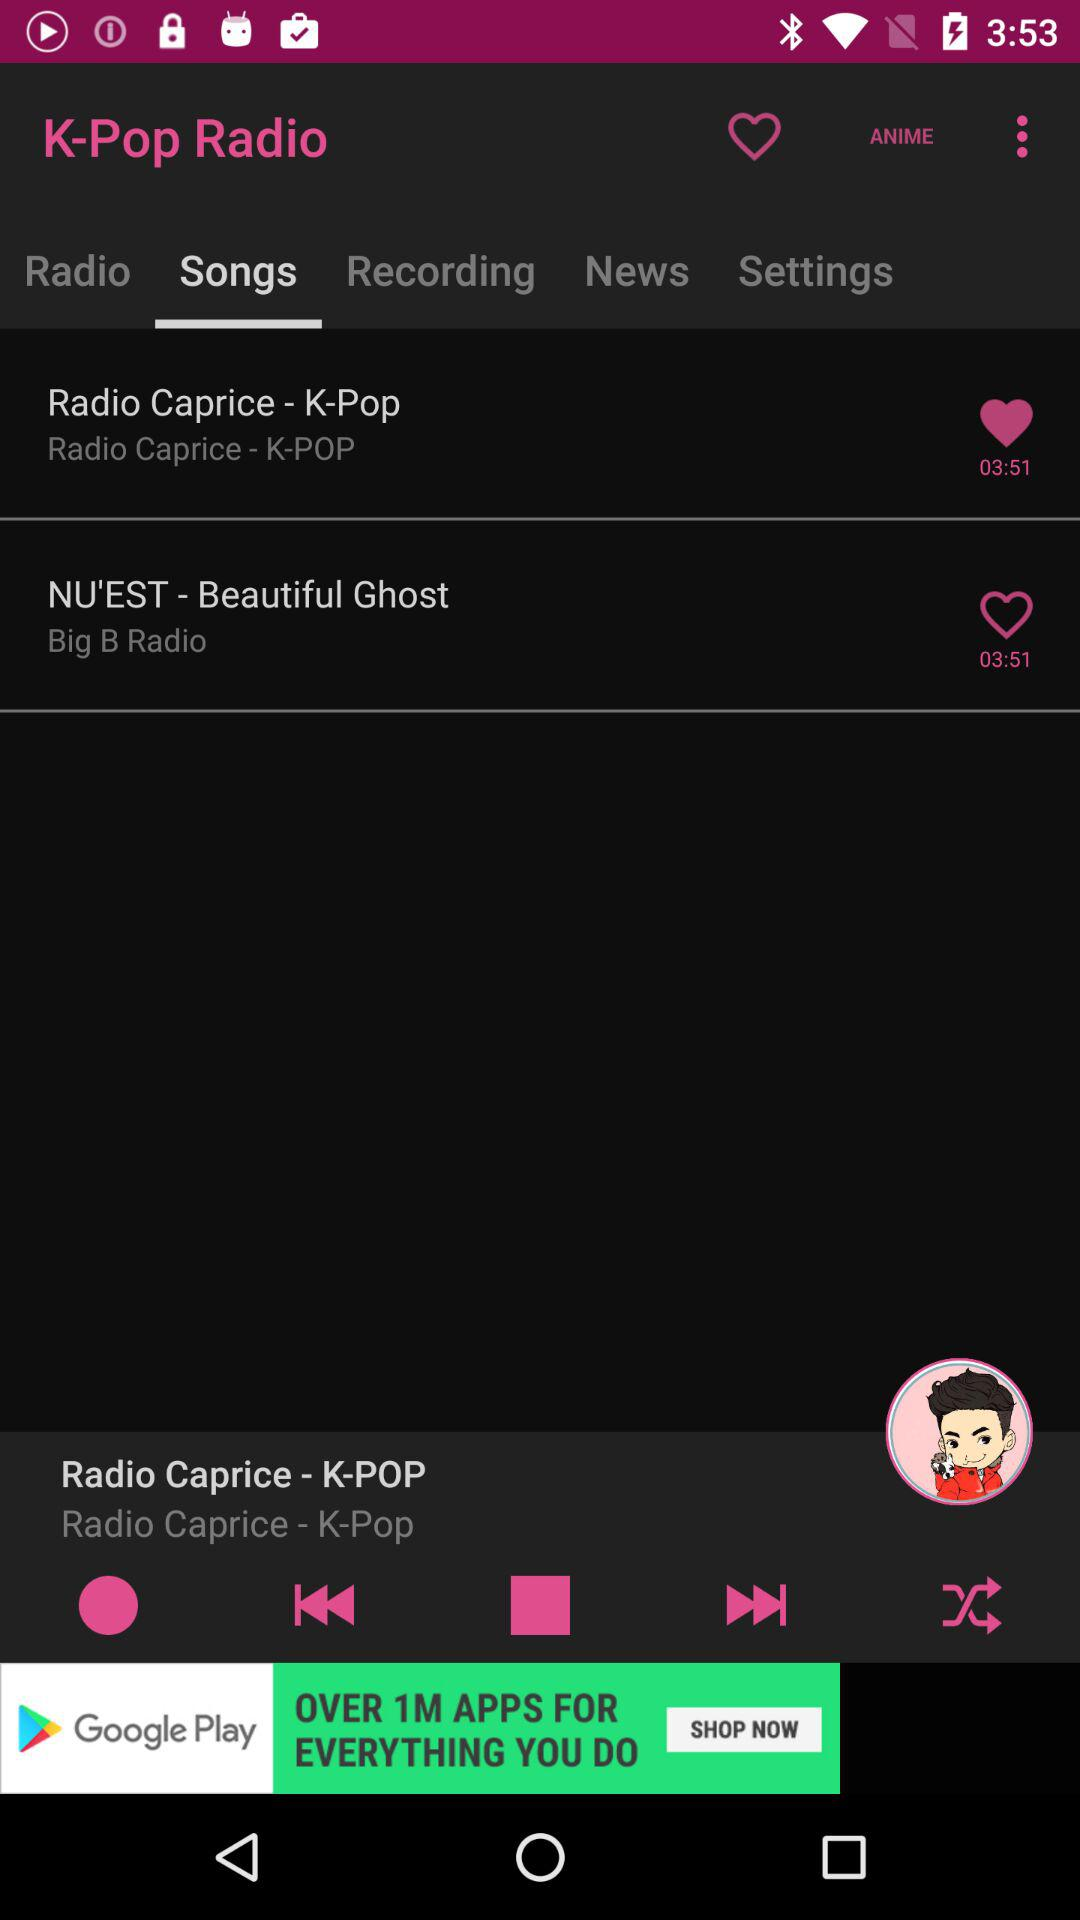Which tab is selected? The selected tab is "Songs". 